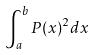Convert formula to latex. <formula><loc_0><loc_0><loc_500><loc_500>\int _ { a } ^ { b } P ( x ) ^ { 2 } d x</formula> 